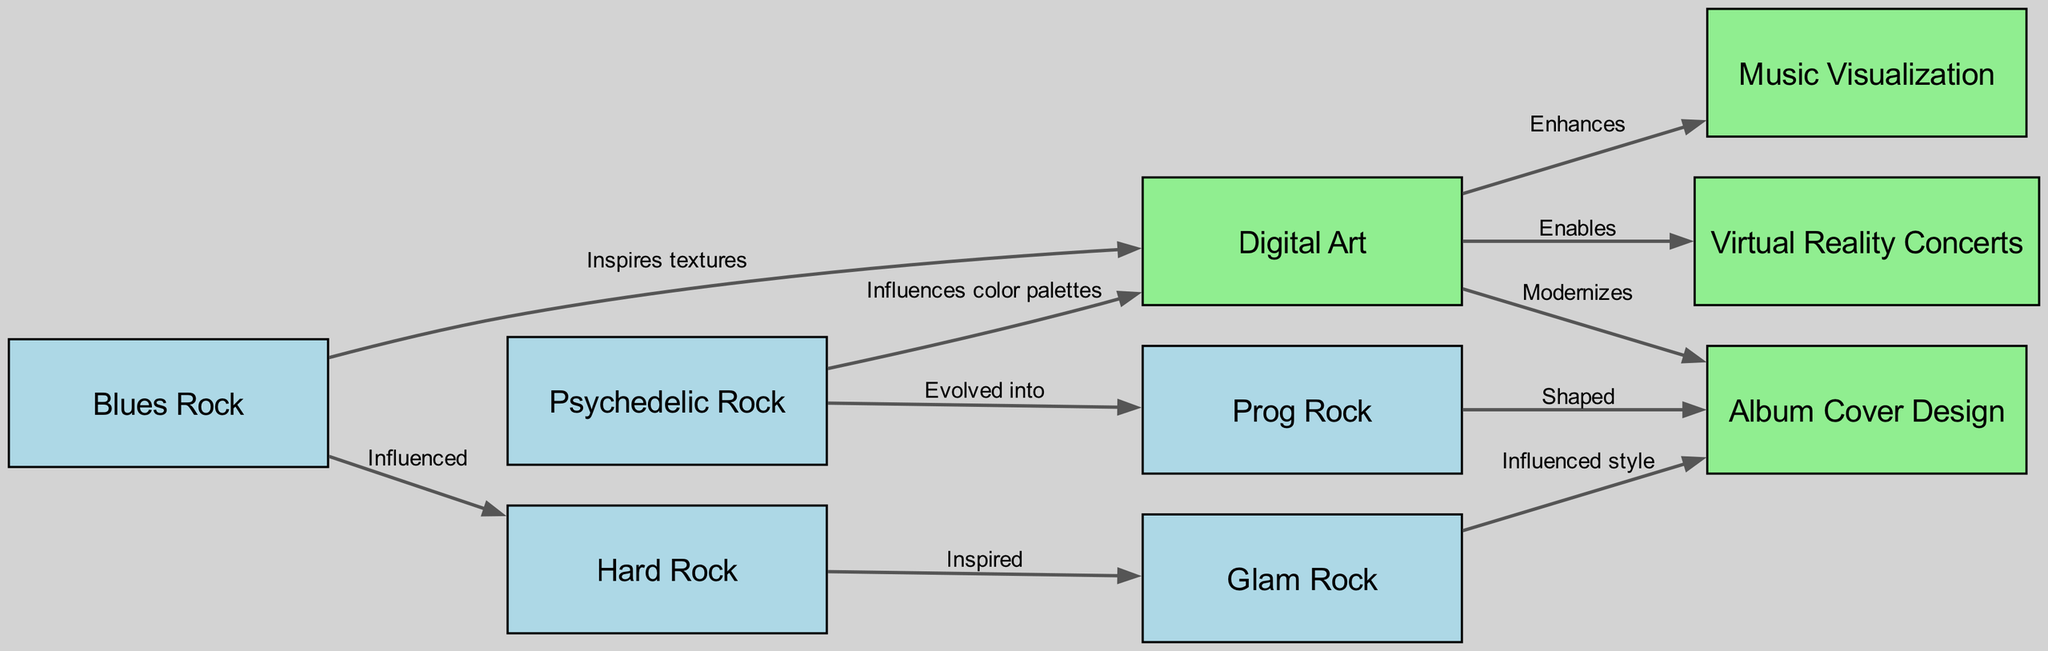What is the total number of nodes in the diagram? The diagram lists 9 distinct entities, which include both classic rock genres and elements of digital art. By counting all unique entries, we determine the total node count as nine.
Answer: 9 Which classic rock genre did Blues Rock influence? Following the directed arrow from Blues Rock, it points directly to Hard Rock, indicating that it influenced this particular genre.
Answer: Hard Rock What type of digital art element does Prog Rock shape? The directed edge from Prog Rock to Album Cover Design shows that it shapes this specific aspect of digital art. Hence, the relationship can be directly followed from the diagram.
Answer: Album Cover Design How many edges are associated with Digital Art? Examining the edges leading from the Digital Art node, we find three outgoing connections. These edges point to Album Cover Design, Music Visualization, and Virtual Reality Concerts. Therefore, the total count of edges related to Digital Art is three.
Answer: 3 Which classic rock genre evolved into Prog Rock? The arrow from Psychedelic Rock that points to Prog Rock indicates a direct evolution from one to the other. Thus, we can easily identify the predecessor of Prog Rock in this context.
Answer: Psychedelic Rock What role does Glam Rock play in Album Cover Design? The edge between Glam Rock and Album Cover Design indicates that Glam Rock influenced the style in this aspect of digital art. This direct influence shows a connection that can be traced in the diagram.
Answer: Influenced style 